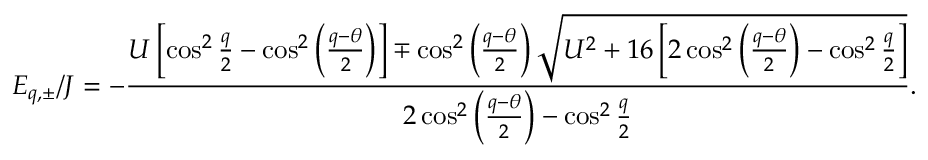Convert formula to latex. <formula><loc_0><loc_0><loc_500><loc_500>E _ { q , \pm } / J = - \frac { U \left [ \cos ^ { 2 } \frac { q } { 2 } - \cos ^ { 2 } \left ( \frac { q - \theta } { 2 } \right ) \right ] \mp \cos ^ { 2 } \left ( \frac { q - \theta } { 2 } \right ) \sqrt { U ^ { 2 } + 1 6 \left [ 2 \cos ^ { 2 } \left ( \frac { q - \theta } { 2 } \right ) - \cos ^ { 2 } \frac { q } { 2 } \right ] } } { 2 \cos ^ { 2 } \left ( \frac { q - \theta } { 2 } \right ) - \cos ^ { 2 } \frac { q } { 2 } } .</formula> 